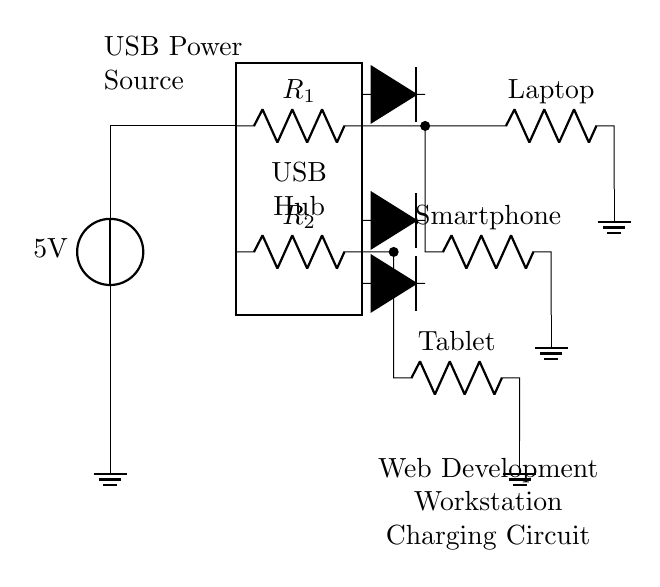What is the power source voltage? The voltage source in the circuit is labeled as 5V, indicating that this is the potential difference provided to the circuit for charging the devices.
Answer: 5V What types of devices are being charged? The circuit diagram shows three devices: a Laptop, a Smartphone, and a Tablet, each connected to the USB hub through resistors.
Answer: Laptop, Smartphone, Tablet How many current limiting resistors are present? There are two resistors indicated in the diagram, labeled R1 and R2, which are used to limit currents to the respective devices connected.
Answer: 2 What is the purpose of the protection diodes? The protection diodes are placed in line with the devices to prevent reverse current flow, thus protecting the circuit and connected devices from potential damage.
Answer: Prevent reverse current What is the configuration of the USB hub in the circuit? The USB hub is represented as a rectangle, serving as a central connection point for the devices, allowing them to draw power from the source and facilitating their charging.
Answer: Central connection point Which devices have separate current limiting resistors? The Laptop and Smartphone are each connected to a current limiting resistor but the Tablet is not shown with its own resistor, receiving power directly from the hub.
Answer: Laptop, Smartphone 